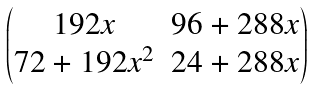Convert formula to latex. <formula><loc_0><loc_0><loc_500><loc_500>\begin{pmatrix} 1 9 2 x & 9 6 + 2 8 8 x \\ 7 2 + 1 9 2 x ^ { 2 } & 2 4 + 2 8 8 x \end{pmatrix}</formula> 